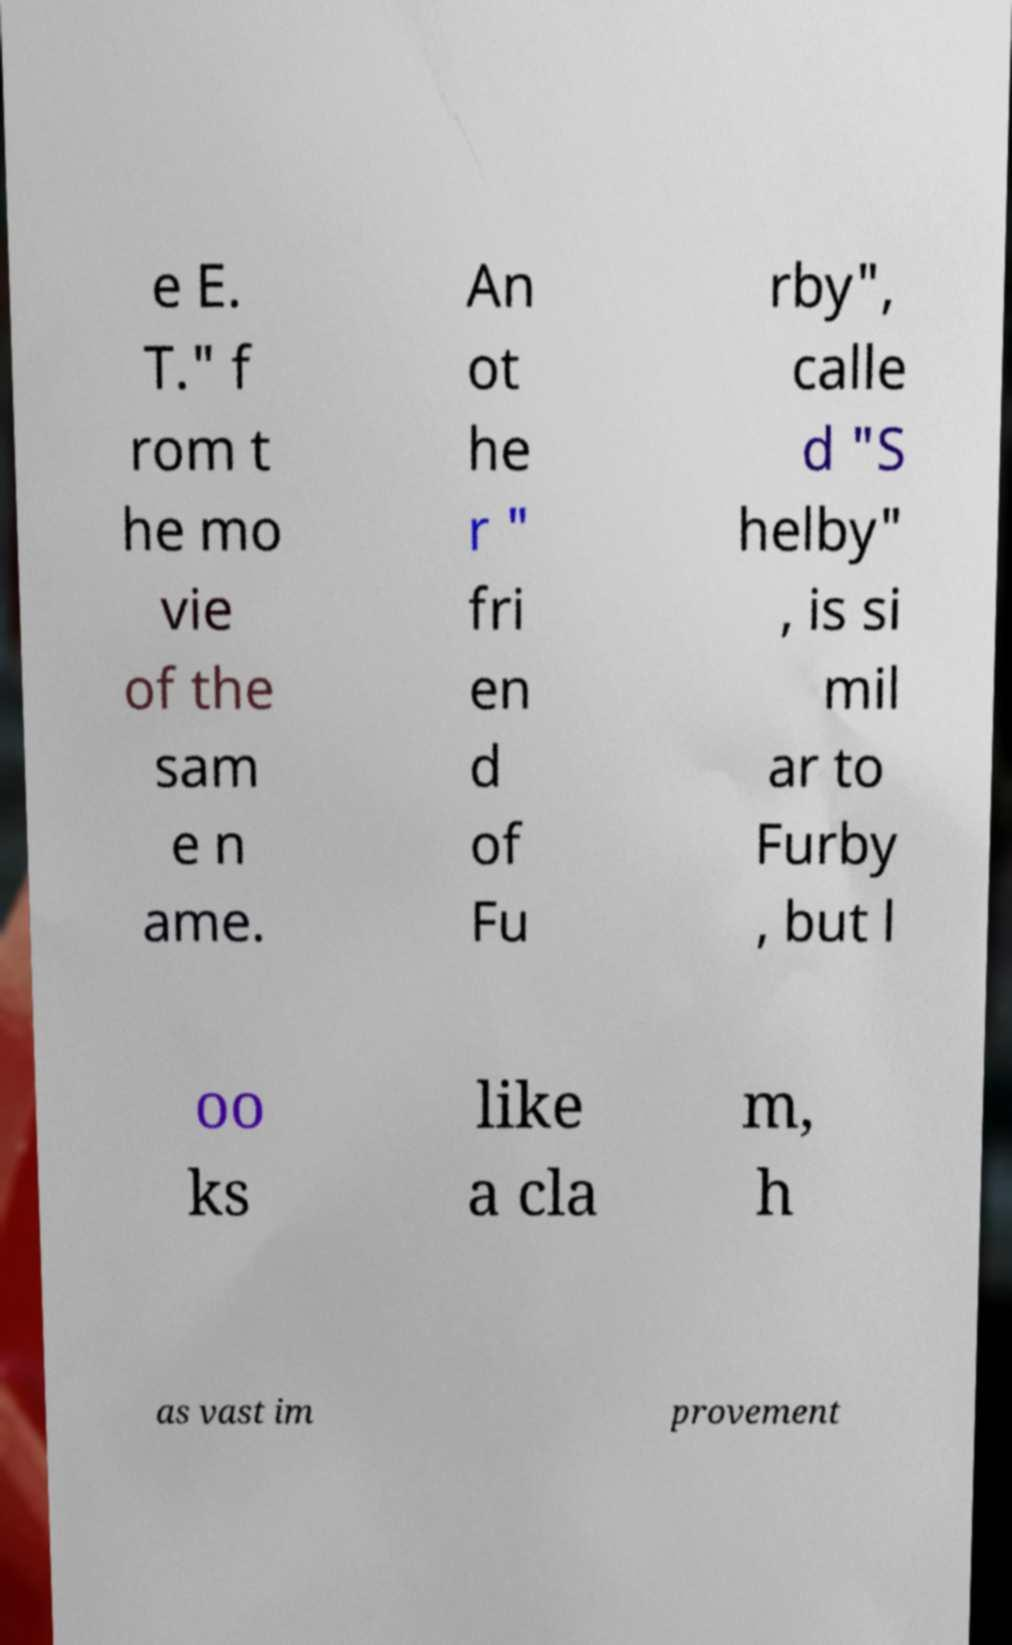Please read and relay the text visible in this image. What does it say? e E. T." f rom t he mo vie of the sam e n ame. An ot he r " fri en d of Fu rby", calle d "S helby" , is si mil ar to Furby , but l oo ks like a cla m, h as vast im provement 